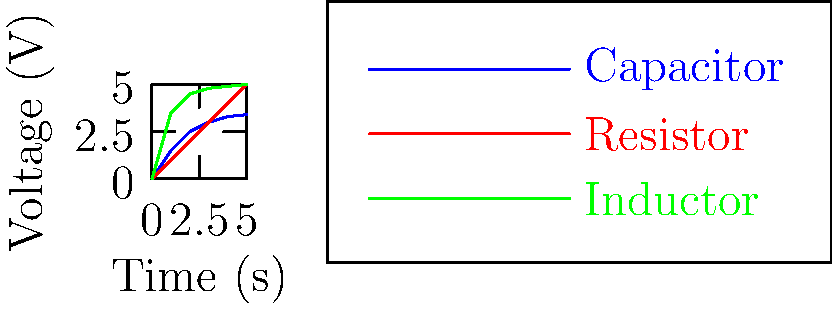In the context of workplace safety regulations for electrical equipment, consider the voltage-time graph shown for three different circuit components. Which component exhibits a constant rate of voltage change over time, potentially posing a consistent risk factor for workers operating this equipment? To answer this question, we need to analyze the voltage-time relationships for each component:

1. Capacitor (blue line):
   - Initially rises quickly
   - Rate of voltage change decreases over time
   - Approaches a maximum voltage asymptotically

2. Resistor (red line):
   - Shows a straight line
   - Constant slope throughout the time period
   - Voltage increases at a constant rate

3. Inductor (green line):
   - Initially rises slowly
   - Rate of voltage change increases over time
   - Approaches a maximum voltage asymptotically

The component with a constant rate of voltage change over time is the one that shows a straight line on the voltage-time graph. This is because a straight line indicates a constant slope, which represents a constant rate of change.

From the graph, we can see that the red line, representing the resistor, is the only one that shows a straight line relationship between voltage and time.
Answer: Resistor 